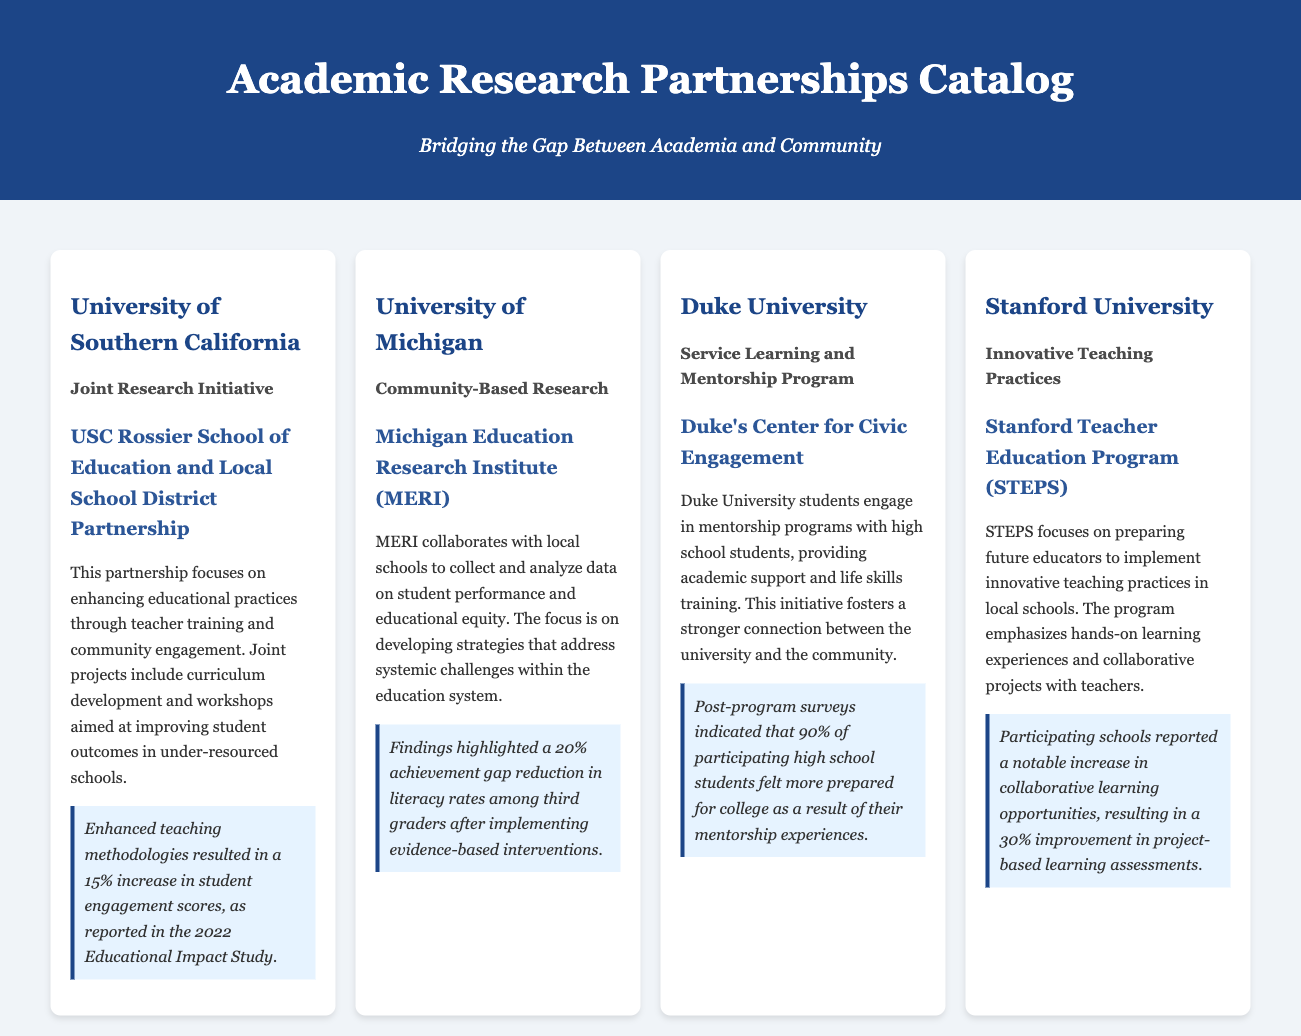What is the name of the partnership between USC and local schools? The partnership is called the USC Rossier School of Education and Local School District Partnership.
Answer: USC Rossier School of Education and Local School District Partnership What is the percentage increase in student engagement scores reported by USC? The document states that enhanced teaching methodologies resulted in a 15% increase in student engagement scores.
Answer: 15% Which university collaborates through the Michigan Education Research Institute (MERI)? The collaboration is mentioned to be with the University of Michigan.
Answer: University of Michigan What was the achievement gap reduction in literacy rates highlighted by findings from MERI? The document indicates that there was a 20% achievement gap reduction in literacy rates among third graders.
Answer: 20% What type of research does Duke University focus on in its partnership? The partnership focuses on Service Learning and Mentorship Programs.
Answer: Service Learning and Mentorship Program What percentage of high school students felt more prepared for college after the mentorship program at Duke? Post-program surveys indicated that 90% felt more prepared for college.
Answer: 90% What initiative does Stanford's Teacher Education Program (STEPS) emphasize? STEPS emphasizes hands-on learning experiences and collaborative projects.
Answer: Hands-on learning experiences How much improvement in project-based learning assessments did participating schools report due to STEPS? The document reports a 30% improvement in project-based learning assessments.
Answer: 30% 